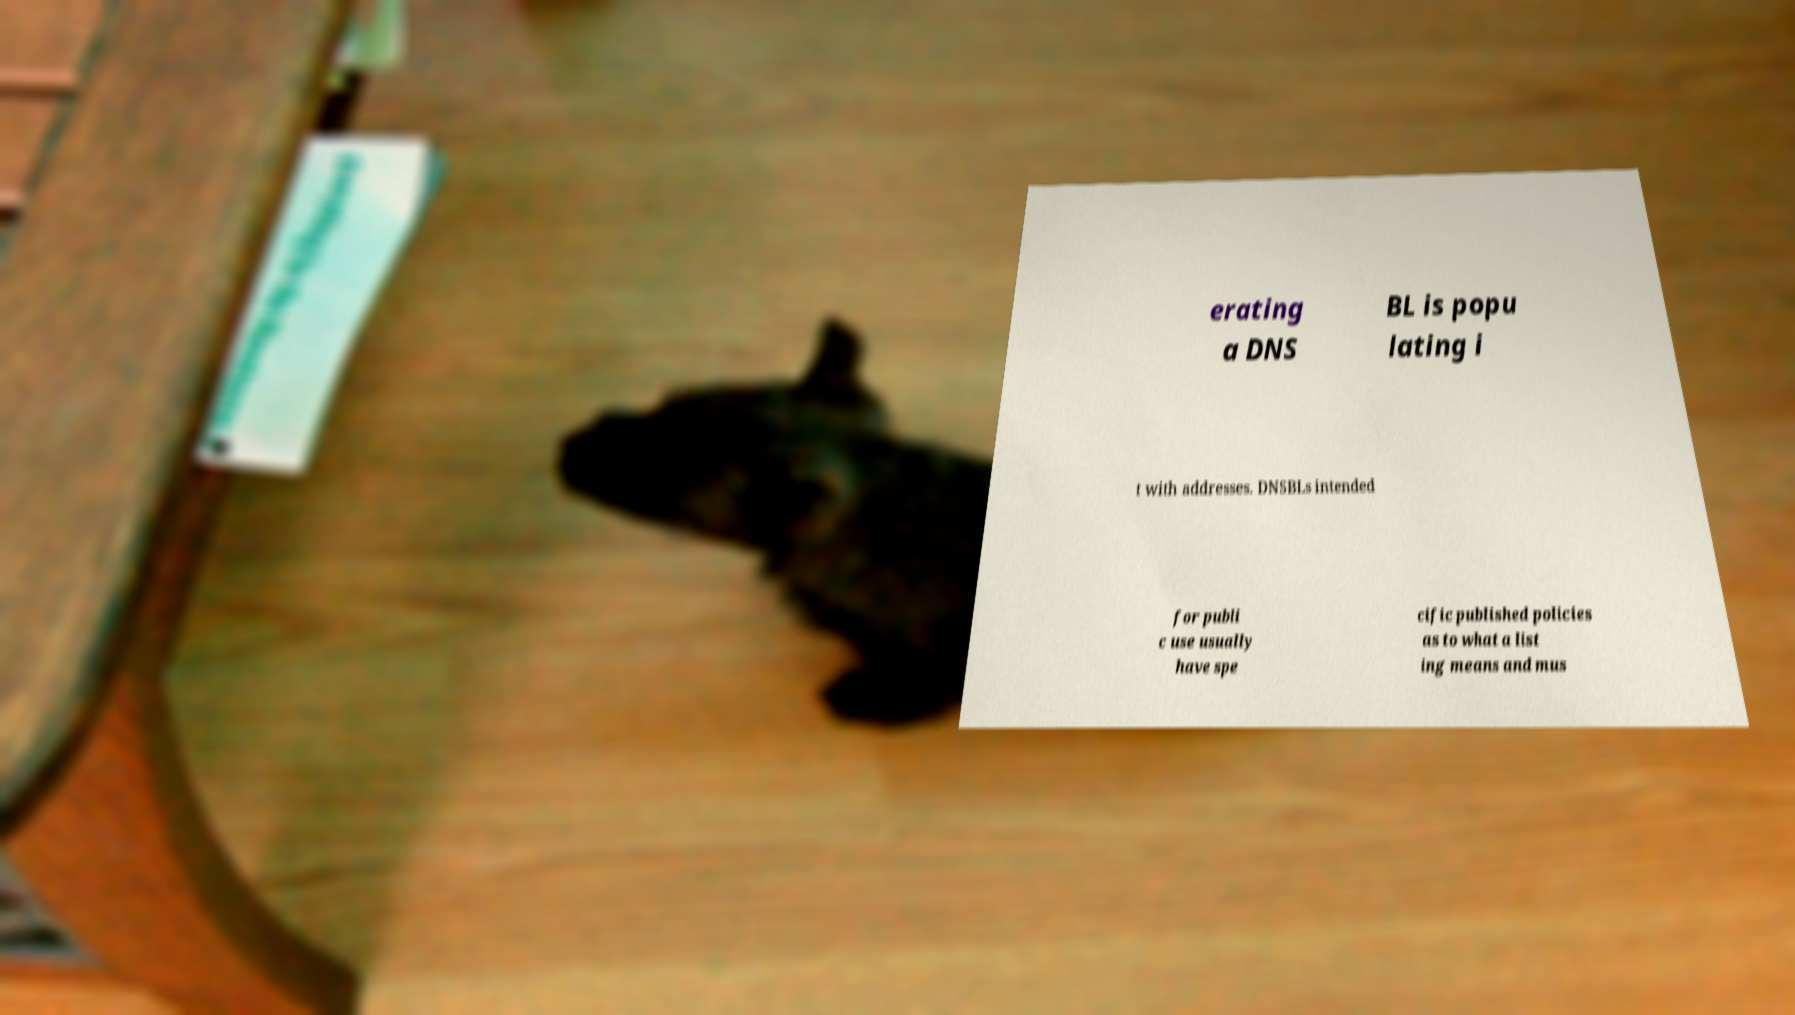For documentation purposes, I need the text within this image transcribed. Could you provide that? erating a DNS BL is popu lating i t with addresses. DNSBLs intended for publi c use usually have spe cific published policies as to what a list ing means and mus 